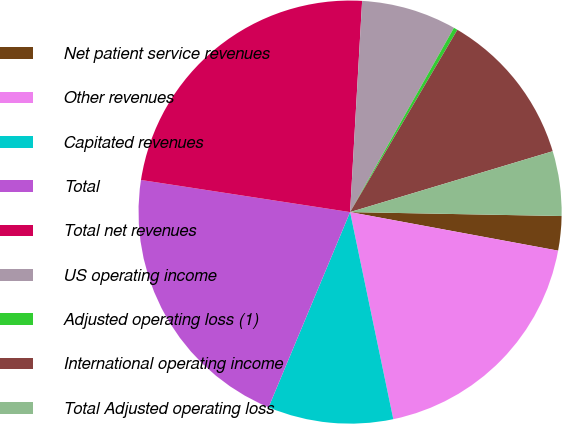Convert chart. <chart><loc_0><loc_0><loc_500><loc_500><pie_chart><fcel>Net patient service revenues<fcel>Other revenues<fcel>Capitated revenues<fcel>Total<fcel>Total net revenues<fcel>US operating income<fcel>Adjusted operating loss (1)<fcel>International operating income<fcel>Total Adjusted operating loss<nl><fcel>2.62%<fcel>18.81%<fcel>9.57%<fcel>21.13%<fcel>23.48%<fcel>7.26%<fcel>0.3%<fcel>11.89%<fcel>4.94%<nl></chart> 